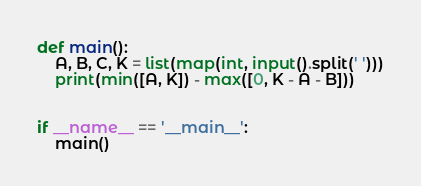<code> <loc_0><loc_0><loc_500><loc_500><_Python_>def main():
    A, B, C, K = list(map(int, input().split(' ')))
    print(min([A, K]) - max([0, K - A - B]))


if __name__ == '__main__':
    main()</code> 